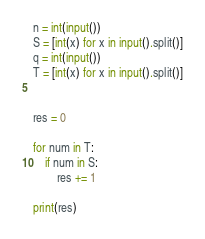<code> <loc_0><loc_0><loc_500><loc_500><_Python_>n = int(input())
S = [int(x) for x in input().split()]
q = int(input())
T = [int(x) for x in input().split()]


res = 0

for num in T:
    if num in S:
        res += 1

print(res)</code> 